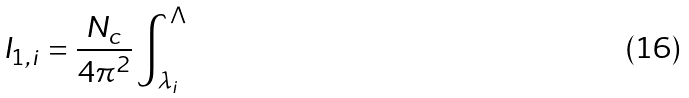Convert formula to latex. <formula><loc_0><loc_0><loc_500><loc_500>I _ { 1 , i } = \frac { N _ { c } } { 4 \pi ^ { 2 } } \int _ { \lambda _ { i } } ^ { \Lambda }</formula> 